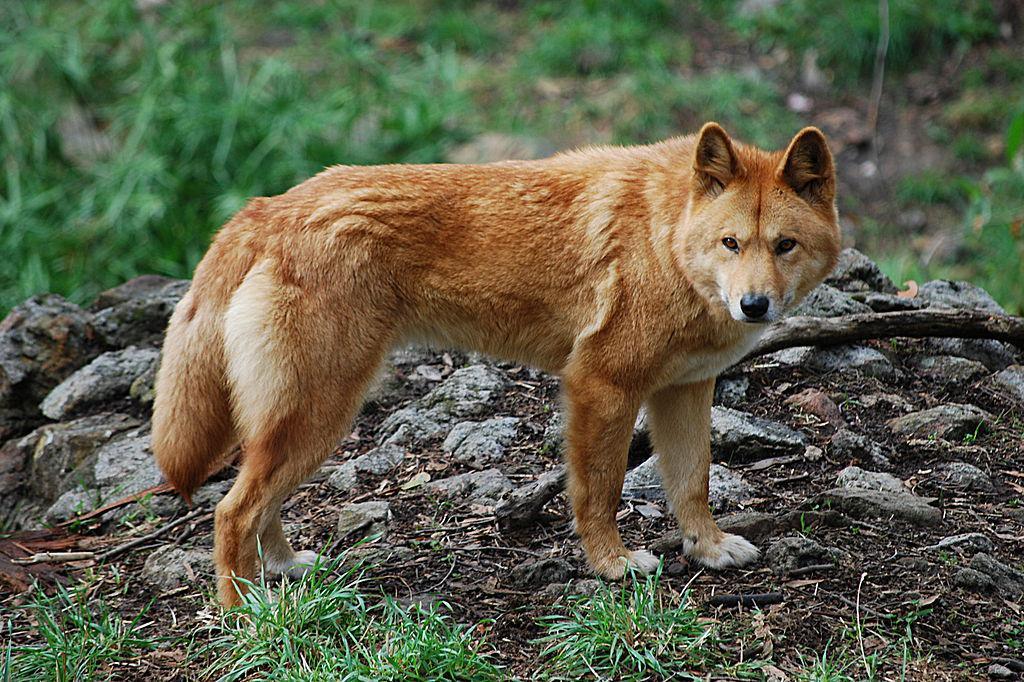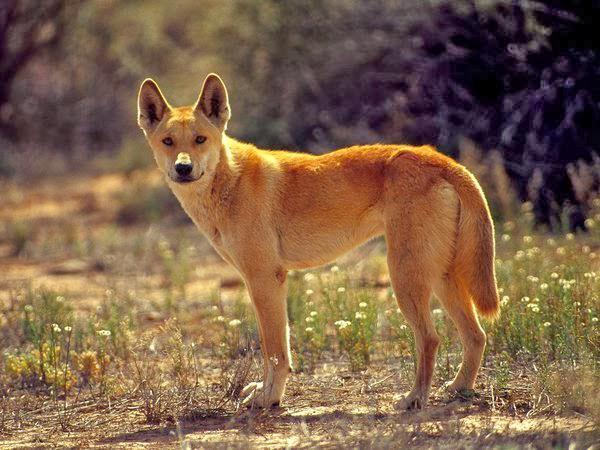The first image is the image on the left, the second image is the image on the right. For the images displayed, is the sentence "There are no more than 3 animals in the pair of images." factually correct? Answer yes or no. Yes. The first image is the image on the left, the second image is the image on the right. Evaluate the accuracy of this statement regarding the images: "The right image contains at least two wolves.". Is it true? Answer yes or no. No. 